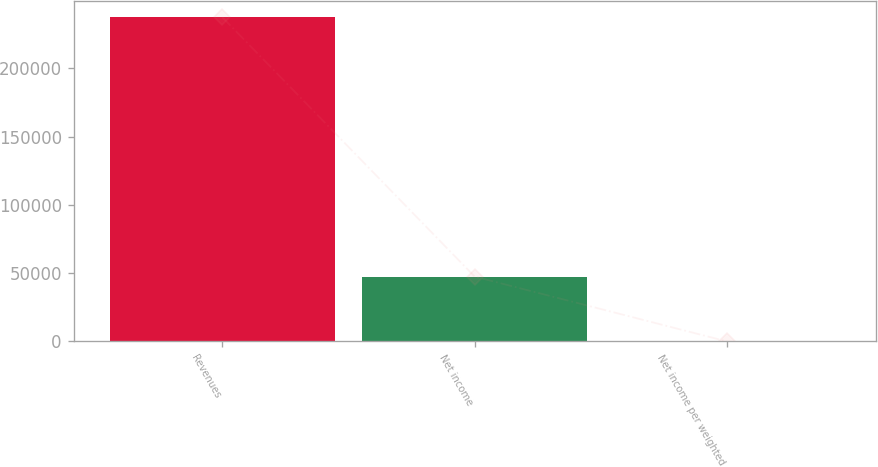Convert chart. <chart><loc_0><loc_0><loc_500><loc_500><bar_chart><fcel>Revenues<fcel>Net income<fcel>Net income per weighted<nl><fcel>237523<fcel>47504.7<fcel>0.16<nl></chart> 